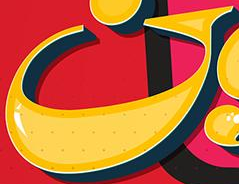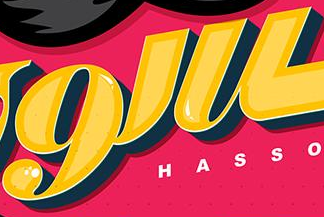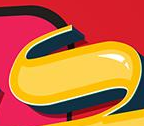Transcribe the words shown in these images in order, separated by a semicolon. G; 9'u; s 